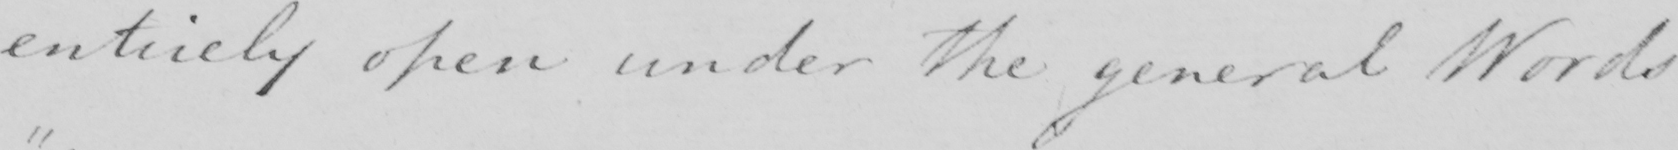What is written in this line of handwriting? entirely open under the general Words 